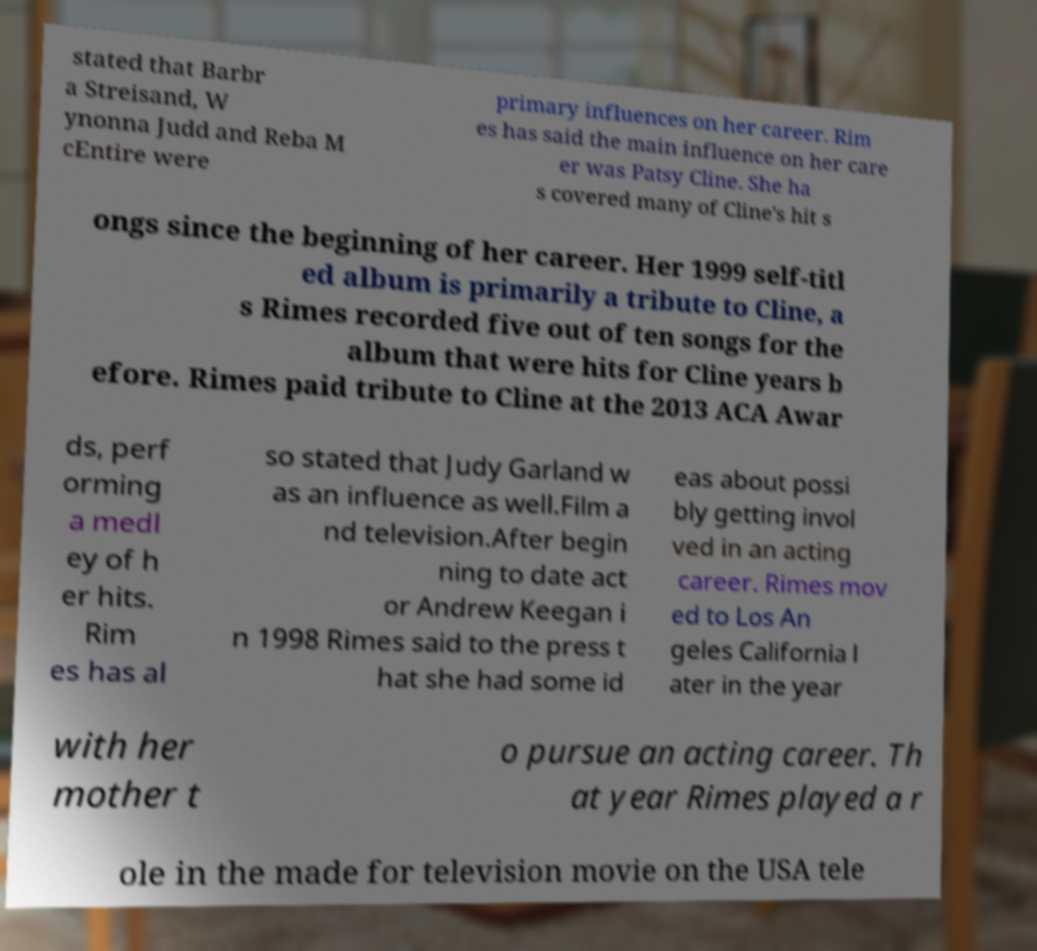For documentation purposes, I need the text within this image transcribed. Could you provide that? stated that Barbr a Streisand, W ynonna Judd and Reba M cEntire were primary influences on her career. Rim es has said the main influence on her care er was Patsy Cline. She ha s covered many of Cline's hit s ongs since the beginning of her career. Her 1999 self-titl ed album is primarily a tribute to Cline, a s Rimes recorded five out of ten songs for the album that were hits for Cline years b efore. Rimes paid tribute to Cline at the 2013 ACA Awar ds, perf orming a medl ey of h er hits. Rim es has al so stated that Judy Garland w as an influence as well.Film a nd television.After begin ning to date act or Andrew Keegan i n 1998 Rimes said to the press t hat she had some id eas about possi bly getting invol ved in an acting career. Rimes mov ed to Los An geles California l ater in the year with her mother t o pursue an acting career. Th at year Rimes played a r ole in the made for television movie on the USA tele 